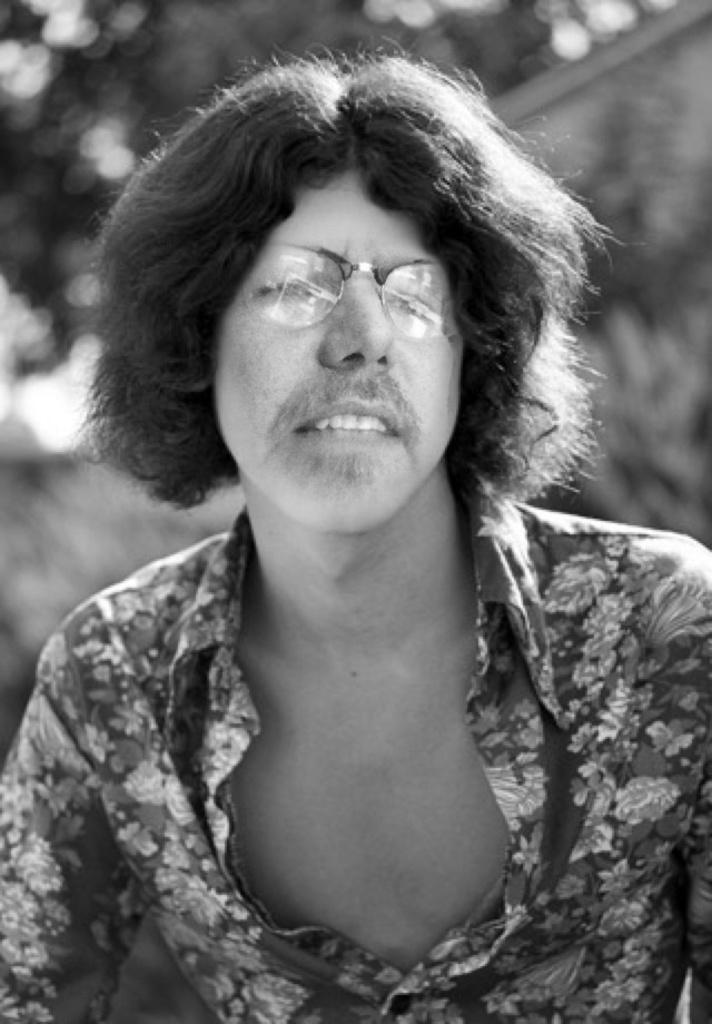Can you describe this image briefly? This is a black and white picture of a person with spectacles , and there is blur background. 